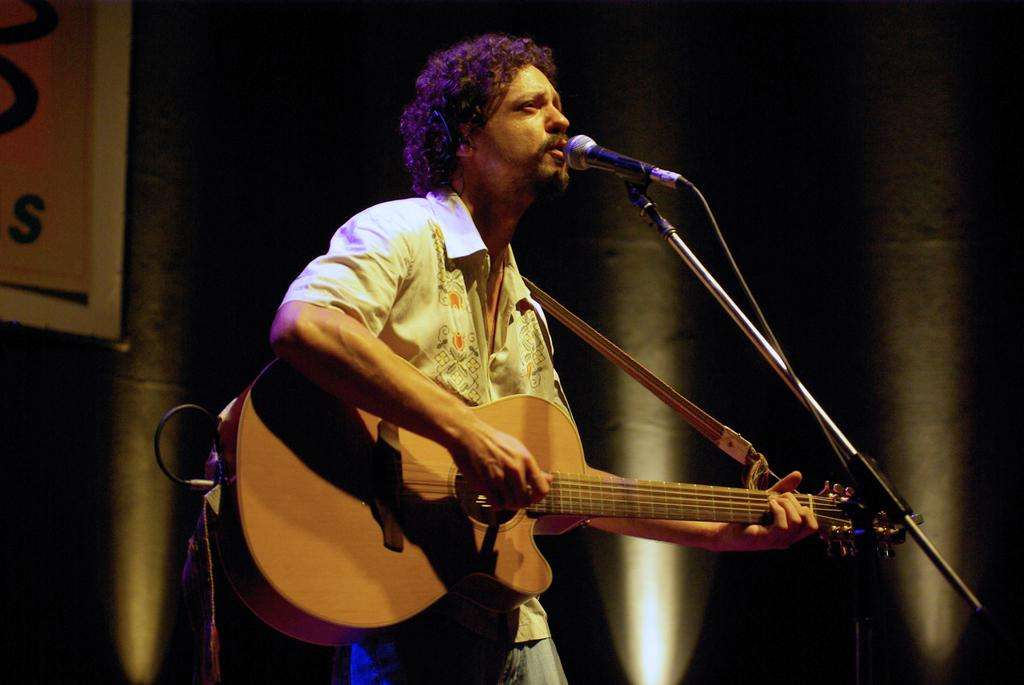What is the main subject of the image? The main subject of the image is a man. What is the man doing in the image? The man is standing in the image. What object is the man holding in his hand? The man is holding a guitar in his hand. What is the purpose of the microphone and stand in front of the man? The microphone and stand are likely used for amplifying the man's voice while playing the guitar. What type of insurance does the man have for his guitar in the image? There is no information about the man's insurance for his guitar in the image. How does the man's haircut contribute to his performance in the image? The image does not show the man's haircut, so it cannot be determined how it might contribute to his performance. 